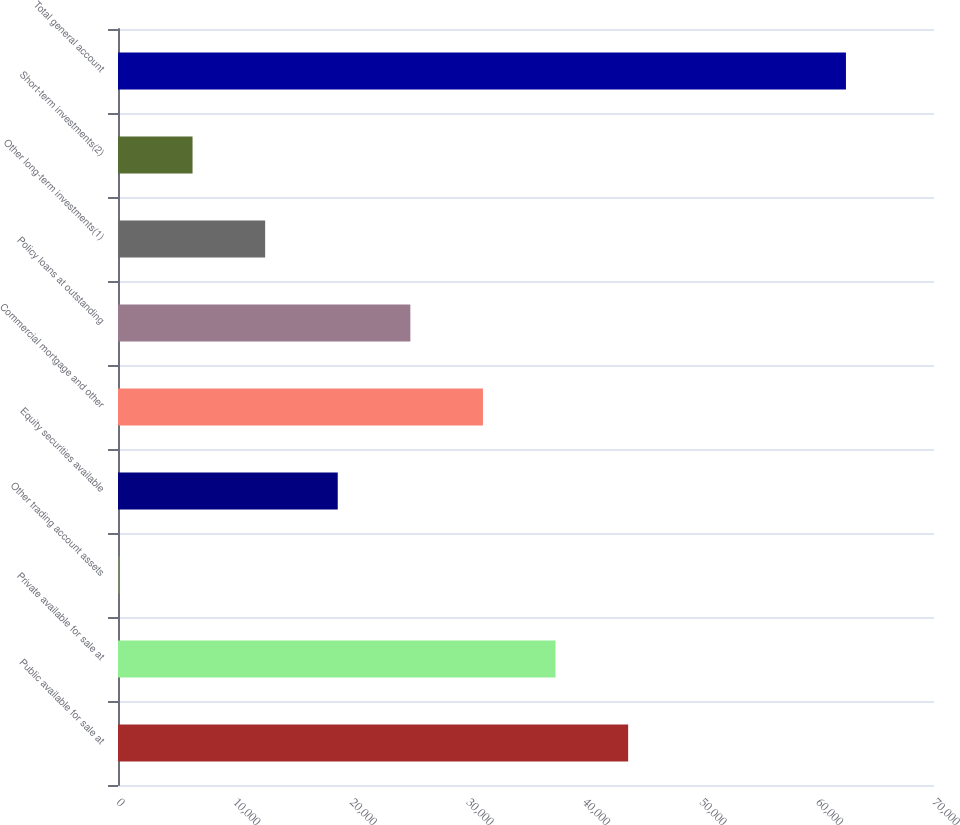Convert chart. <chart><loc_0><loc_0><loc_500><loc_500><bar_chart><fcel>Public available for sale at<fcel>Private available for sale at<fcel>Other trading account assets<fcel>Equity securities available<fcel>Commercial mortgage and other<fcel>Policy loans at outstanding<fcel>Other long-term investments(1)<fcel>Short-term investments(2)<fcel>Total general account<nl><fcel>43763<fcel>37535<fcel>167<fcel>18851<fcel>31307<fcel>25079<fcel>12623<fcel>6395<fcel>62447<nl></chart> 